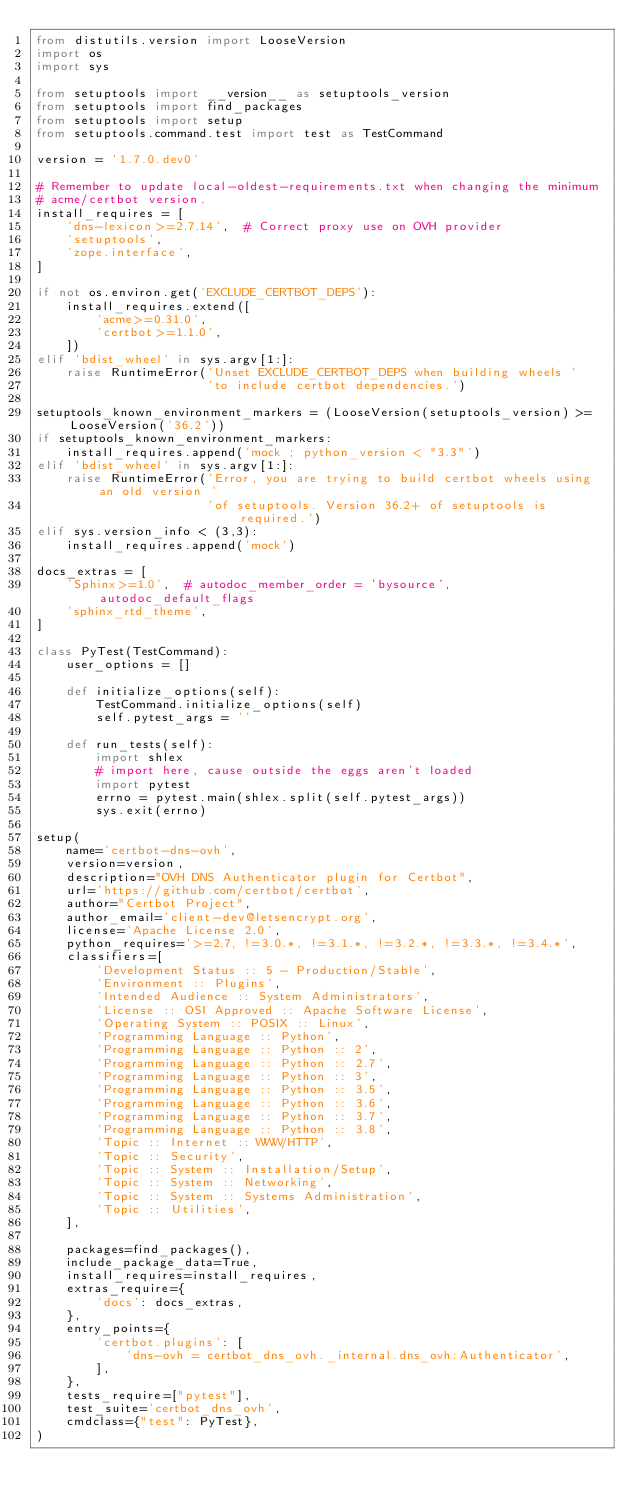Convert code to text. <code><loc_0><loc_0><loc_500><loc_500><_Python_>from distutils.version import LooseVersion
import os
import sys

from setuptools import __version__ as setuptools_version
from setuptools import find_packages
from setuptools import setup
from setuptools.command.test import test as TestCommand

version = '1.7.0.dev0'

# Remember to update local-oldest-requirements.txt when changing the minimum
# acme/certbot version.
install_requires = [
    'dns-lexicon>=2.7.14',  # Correct proxy use on OVH provider
    'setuptools',
    'zope.interface',
]

if not os.environ.get('EXCLUDE_CERTBOT_DEPS'):
    install_requires.extend([
        'acme>=0.31.0',
        'certbot>=1.1.0',
    ])
elif 'bdist_wheel' in sys.argv[1:]:
    raise RuntimeError('Unset EXCLUDE_CERTBOT_DEPS when building wheels '
                       'to include certbot dependencies.')

setuptools_known_environment_markers = (LooseVersion(setuptools_version) >= LooseVersion('36.2'))
if setuptools_known_environment_markers:
    install_requires.append('mock ; python_version < "3.3"')
elif 'bdist_wheel' in sys.argv[1:]:
    raise RuntimeError('Error, you are trying to build certbot wheels using an old version '
                       'of setuptools. Version 36.2+ of setuptools is required.')
elif sys.version_info < (3,3):
    install_requires.append('mock')

docs_extras = [
    'Sphinx>=1.0',  # autodoc_member_order = 'bysource', autodoc_default_flags
    'sphinx_rtd_theme',
]

class PyTest(TestCommand):
    user_options = []

    def initialize_options(self):
        TestCommand.initialize_options(self)
        self.pytest_args = ''

    def run_tests(self):
        import shlex
        # import here, cause outside the eggs aren't loaded
        import pytest
        errno = pytest.main(shlex.split(self.pytest_args))
        sys.exit(errno)

setup(
    name='certbot-dns-ovh',
    version=version,
    description="OVH DNS Authenticator plugin for Certbot",
    url='https://github.com/certbot/certbot',
    author="Certbot Project",
    author_email='client-dev@letsencrypt.org',
    license='Apache License 2.0',
    python_requires='>=2.7, !=3.0.*, !=3.1.*, !=3.2.*, !=3.3.*, !=3.4.*',
    classifiers=[
        'Development Status :: 5 - Production/Stable',
        'Environment :: Plugins',
        'Intended Audience :: System Administrators',
        'License :: OSI Approved :: Apache Software License',
        'Operating System :: POSIX :: Linux',
        'Programming Language :: Python',
        'Programming Language :: Python :: 2',
        'Programming Language :: Python :: 2.7',
        'Programming Language :: Python :: 3',
        'Programming Language :: Python :: 3.5',
        'Programming Language :: Python :: 3.6',
        'Programming Language :: Python :: 3.7',
        'Programming Language :: Python :: 3.8',
        'Topic :: Internet :: WWW/HTTP',
        'Topic :: Security',
        'Topic :: System :: Installation/Setup',
        'Topic :: System :: Networking',
        'Topic :: System :: Systems Administration',
        'Topic :: Utilities',
    ],

    packages=find_packages(),
    include_package_data=True,
    install_requires=install_requires,
    extras_require={
        'docs': docs_extras,
    },
    entry_points={
        'certbot.plugins': [
            'dns-ovh = certbot_dns_ovh._internal.dns_ovh:Authenticator',
        ],
    },
    tests_require=["pytest"],
    test_suite='certbot_dns_ovh',
    cmdclass={"test": PyTest},
)
</code> 